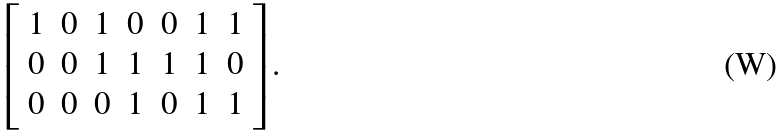<formula> <loc_0><loc_0><loc_500><loc_500>\left [ \begin{array} { c c c c c c c } 1 & 0 & 1 & 0 & 0 & 1 & 1 \\ 0 & 0 & 1 & 1 & 1 & 1 & 0 \\ 0 & 0 & 0 & 1 & 0 & 1 & 1 \end{array} \right ] .</formula> 